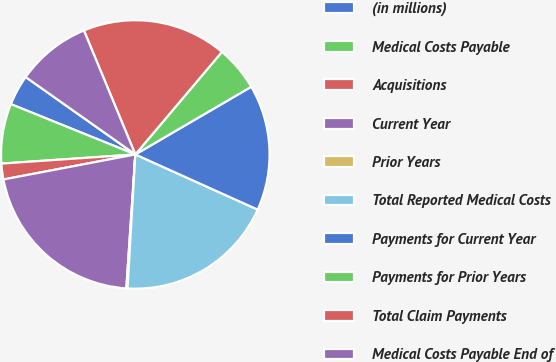Convert chart. <chart><loc_0><loc_0><loc_500><loc_500><pie_chart><fcel>(in millions)<fcel>Medical Costs Payable<fcel>Acquisitions<fcel>Current Year<fcel>Prior Years<fcel>Total Reported Medical Costs<fcel>Payments for Current Year<fcel>Payments for Prior Years<fcel>Total Claim Payments<fcel>Medical Costs Payable End of<nl><fcel>3.67%<fcel>7.2%<fcel>1.9%<fcel>20.95%<fcel>0.14%<fcel>19.19%<fcel>15.15%<fcel>5.43%<fcel>17.42%<fcel>8.96%<nl></chart> 